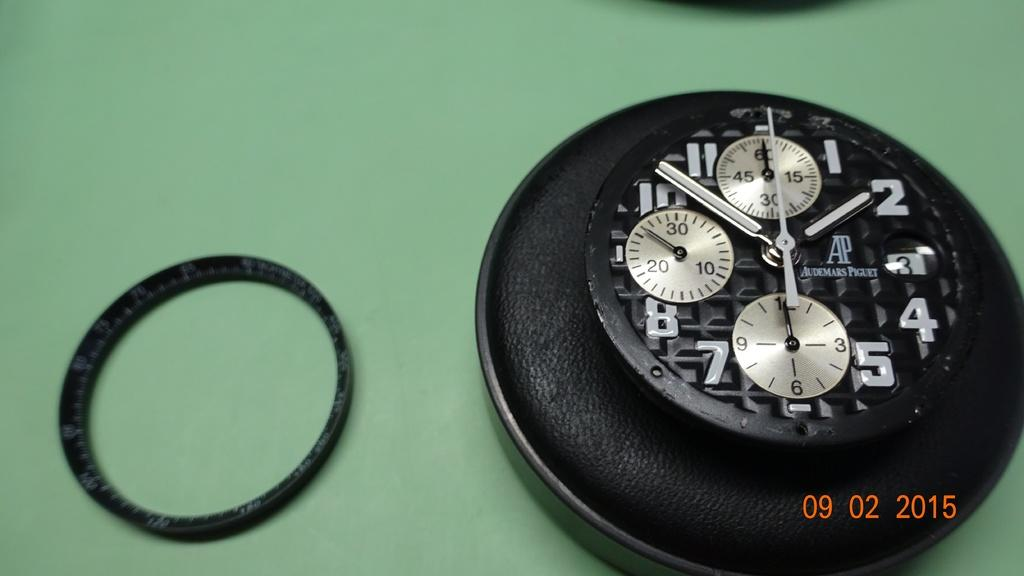Provide a one-sentence caption for the provided image. Face of a watch with the word Audemars Piguet on it as well. 